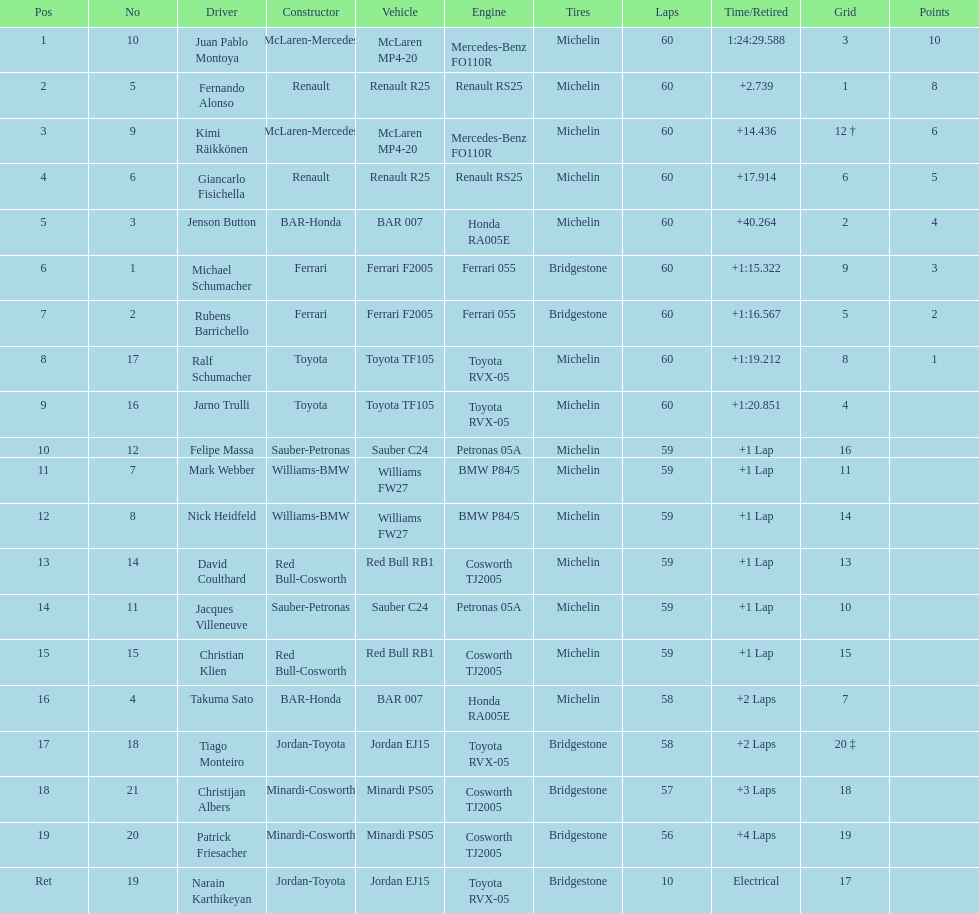How many drivers from germany? 3. 